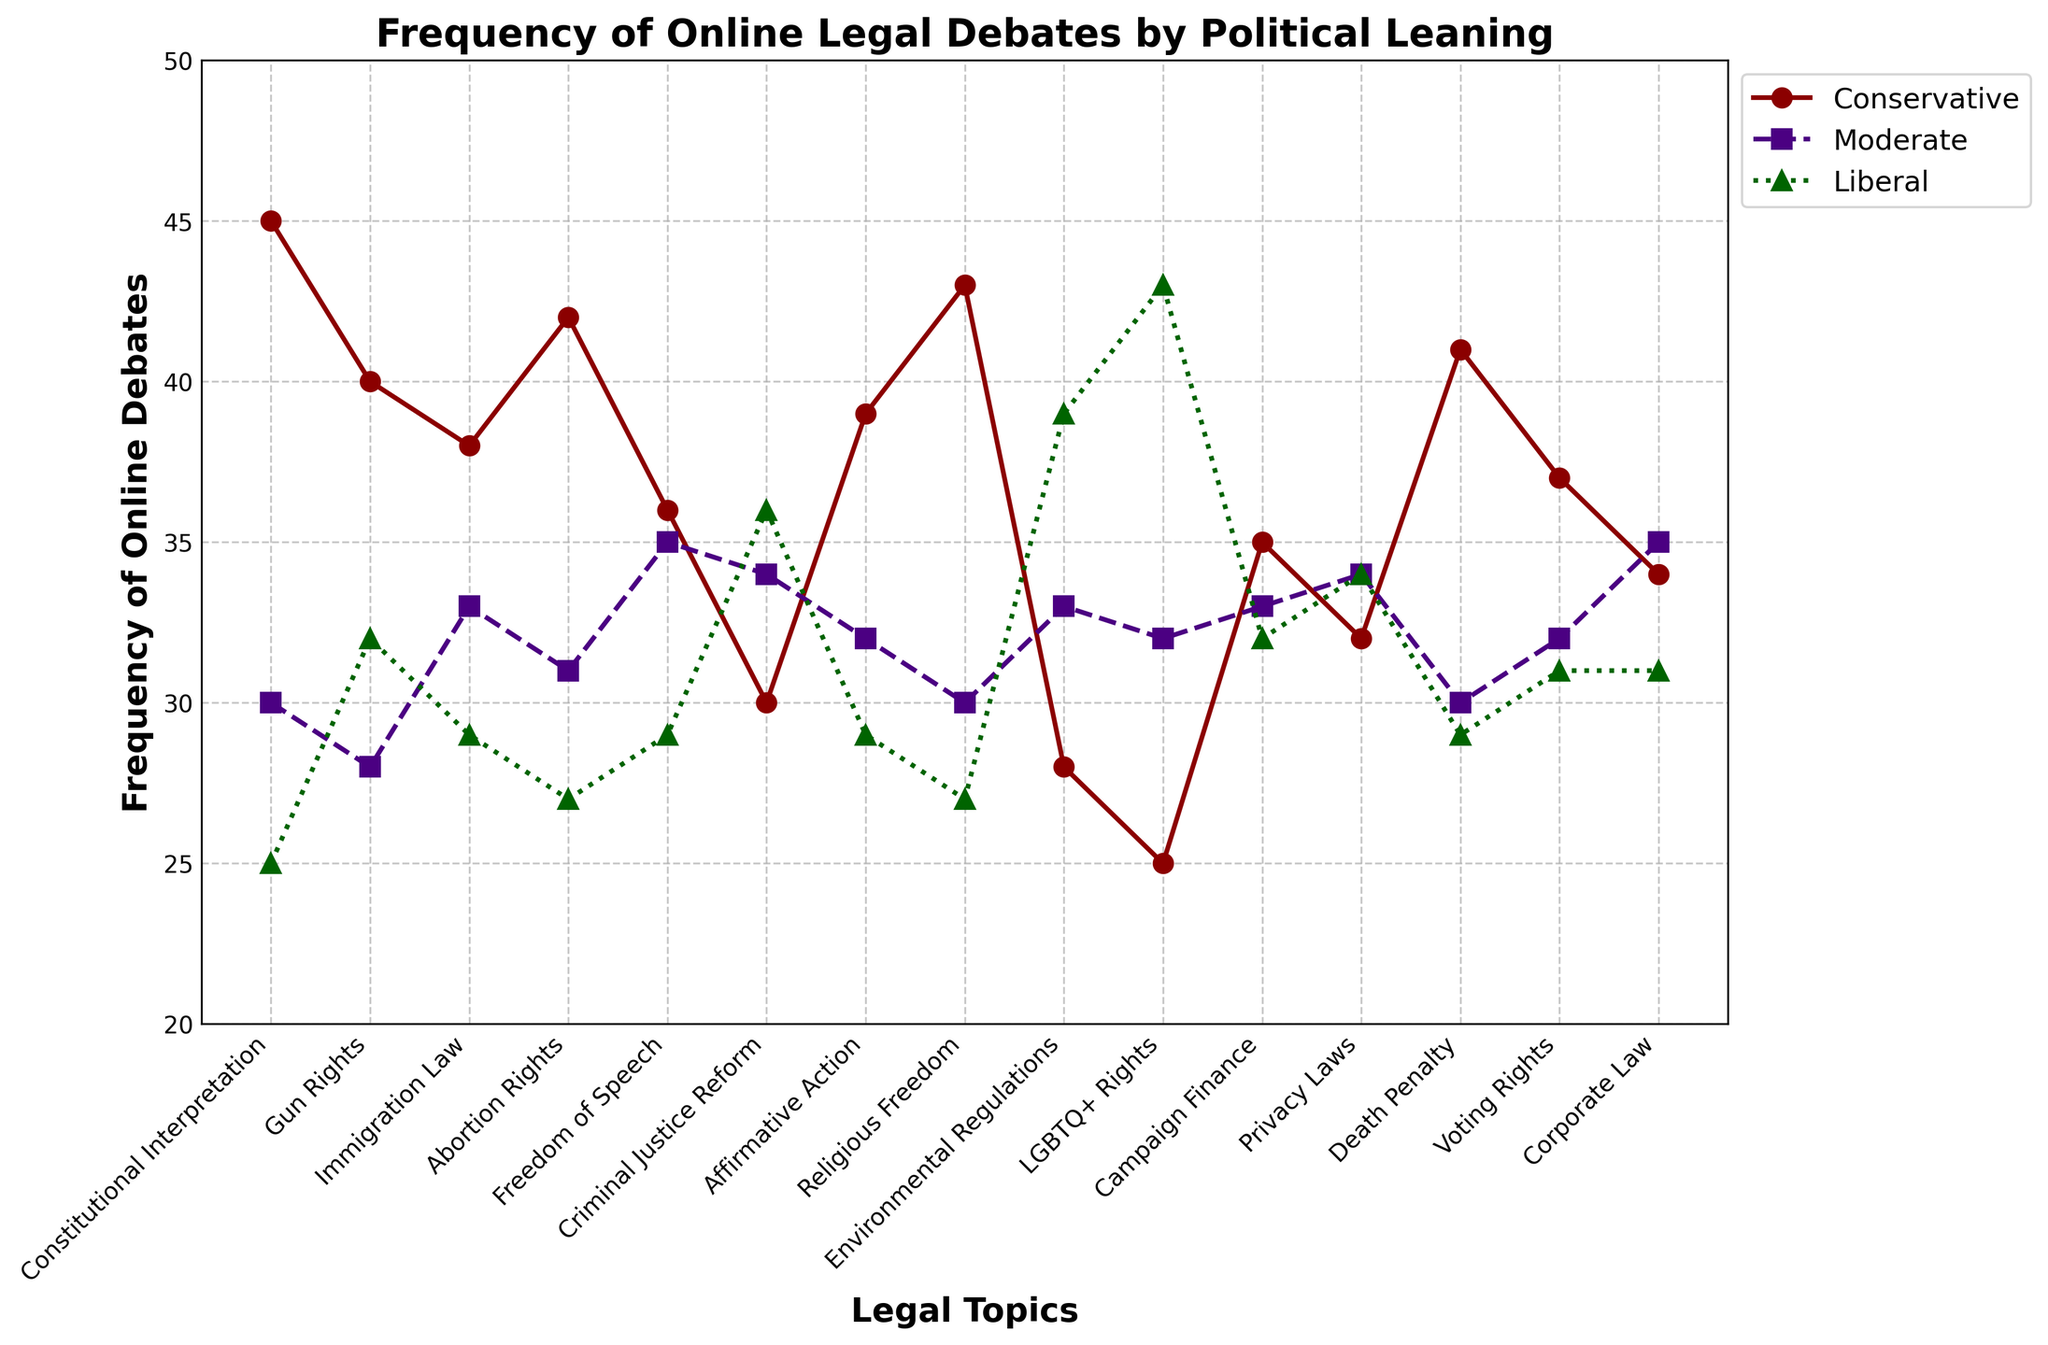Which political leaning has the highest frequency of debates on Environmental Regulations? Look at the Environmental Regulations topic, find the highest point among Conservative, Moderate, and Liberal. The highest point for Environmental Regulations is for Liberal.
Answer: Liberal What is the difference in debate frequency between Conservative and Liberal views on Freedom of Speech? Check the Freedom of Speech topic in the figure. Conservative has a frequency of 36 and Liberal has a frequency of 29. The difference is 36 - 29.
Answer: 7 Which topic shows the closest frequency of debates among all three political leanings? Identify the topic where the points for Conservative, Moderate, and Liberal lines are closest together. Freedom of Speech (Conservative = 36, Moderate = 35, Liberal = 29) and Privacy Laws (Conservative = 32, Moderate = 34, Liberal = 34) are close, but Privacy Laws has the smallest range.
Answer: Privacy Laws What is the average frequency of debates on Abortion Rights across all political leanings? Sum the frequency for Abortion Rights across Conservative (42), Moderate (31), and Liberal (27), then divide by 3. (42 + 31 + 27) / 3 = 33.33
Answer: 33.33 Which topic has the highest debate frequency for Conservative and the lowest for Liberal? Find the peak in the Conservative line and check the corresponding topic in the Liberal line for the lowest value. Constitutional Interpretation has the highest for Conservative at 45 and the lowest for Liberal at 25.
Answer: Constitutional Interpretation Comparing Gun Rights and Criminal Justice Reform, which topic has a higher frequency for Liberal? Look at both Gun Rights (32) and Criminal Justice Reform (36) frequencies for Liberal views. Criminal Justice Reform has a higher frequency for Liberal views.
Answer: Criminal Justice Reform What is the sum of the debate frequencies for Moderate views on Immigration Law and Voting Rights? Add the frequencies for Moderate views on Immigration Law (33) and Voting Rights (32). 33 + 32 = 65.
Answer: 65 How many more debates are there on Gun Rights among Conservatives compared to Moderates? Check the frequencies for Gun Rights: Conservative (40) and Moderate (28). Subtract Moderate's frequency from Conservative's frequency: 40 - 28.
Answer: 12 For which topic do Conservatives and Liberals have the same debate frequency? Identify any overlap in frequency values between Conservative and Liberal across all topics. Privacy Laws, with both having a frequency of 32 for Conservative and Liberal.
Answer: Privacy Laws 